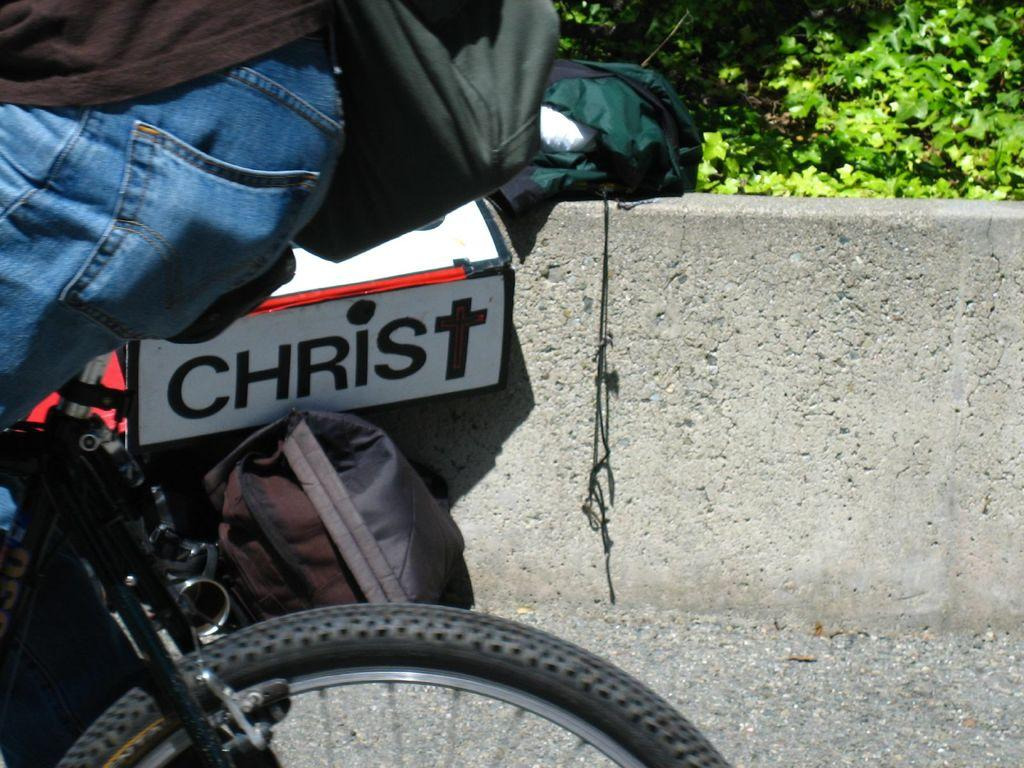What is the main subject in the foreground of the image? There is a person riding a cycle in the foreground of the image. What is the person wearing that is visible in the image? The person is wearing a bag. What can be seen behind the cycle in the image? There is a box and two bags behind the cycle. What is visible in the background of the image? There is a wall in the background of the image. What type of natural environment is visible at the top of the image? There is greenery visible at the top of the image. What type of government is depicted in the image? There is no depiction of a government in the image; it features a person riding a cycle and related objects. Can you tell me how many vans are visible in the image? There are no vans present in the image. 